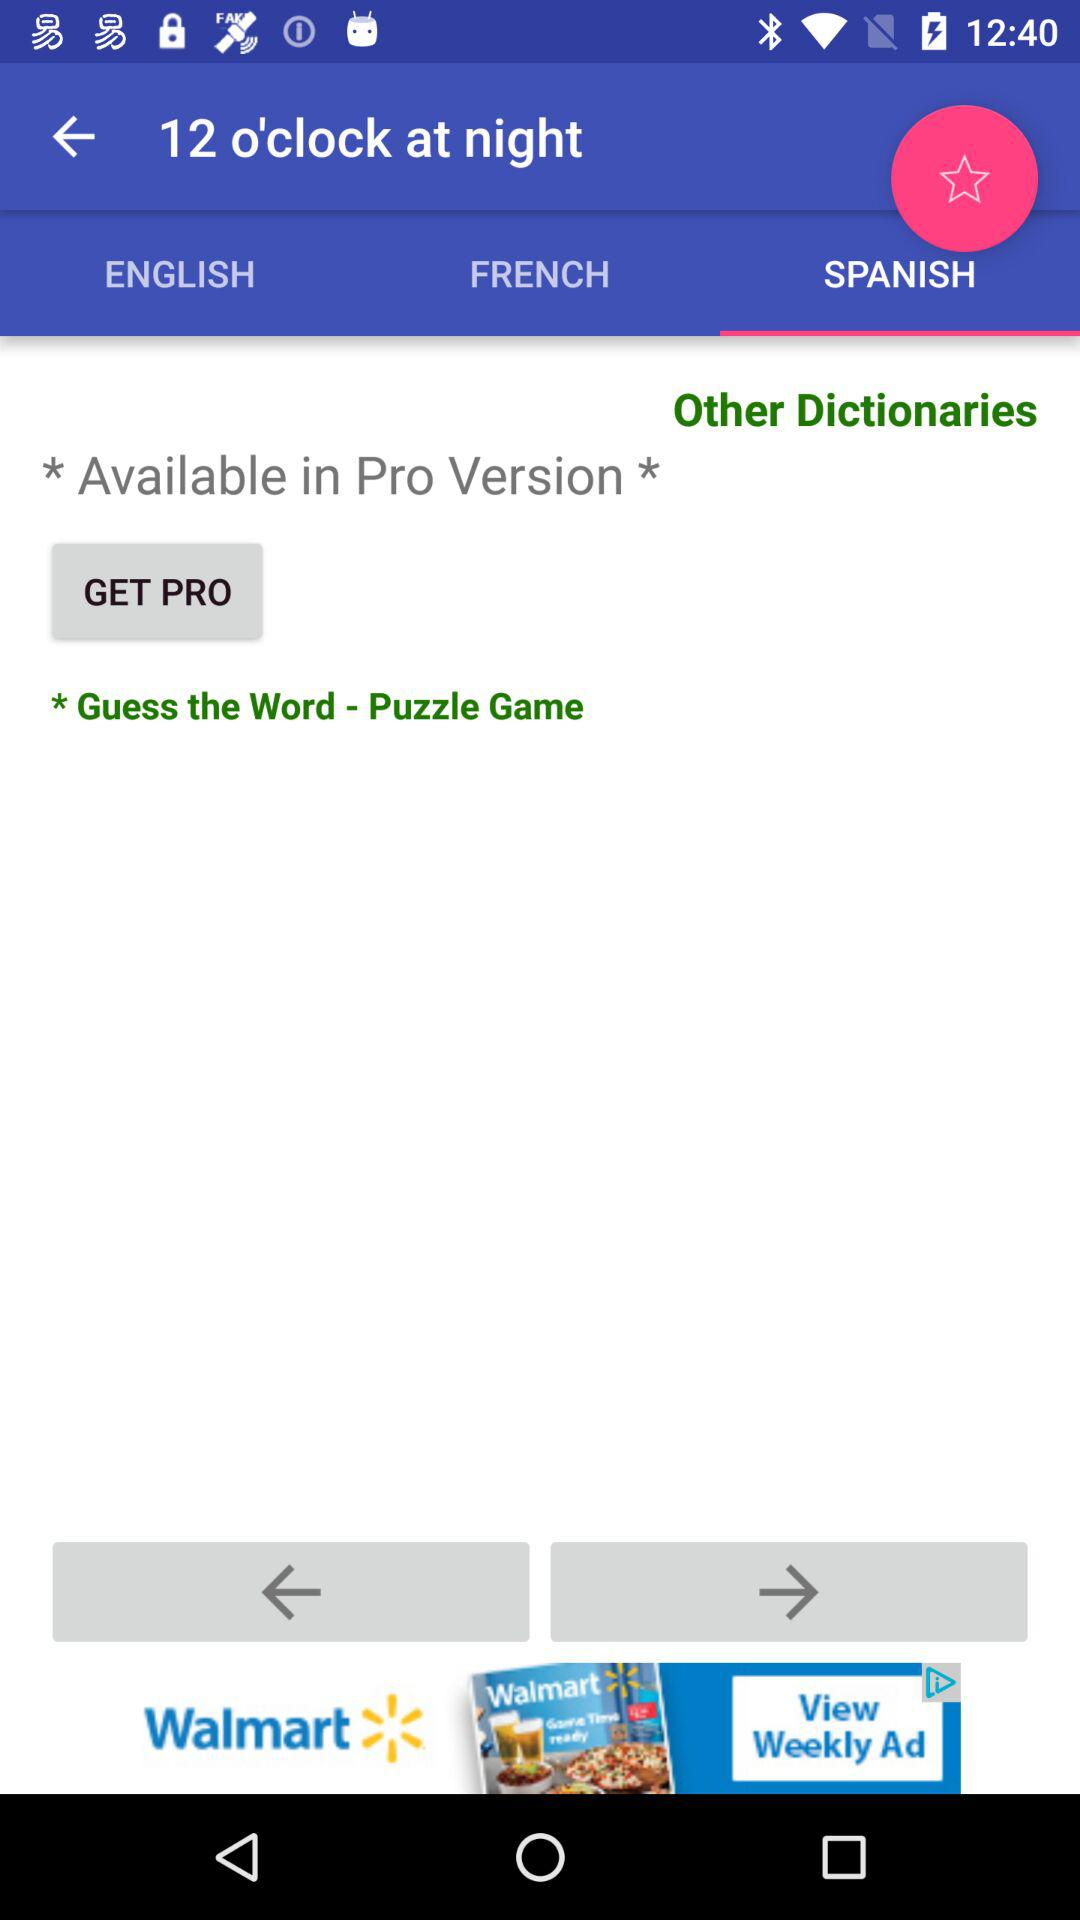How many languages are available in the app?
Answer the question using a single word or phrase. 3 